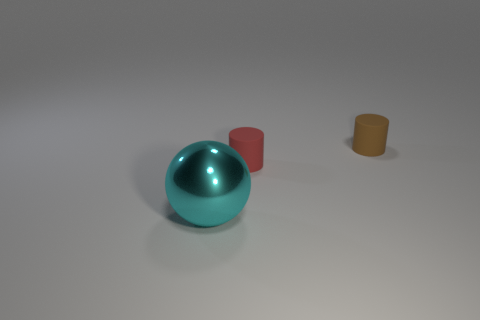Is the color of the big sphere the same as the rubber cylinder that is in front of the tiny brown thing?
Provide a succinct answer. No. Are there an equal number of cyan things that are on the right side of the large metallic object and big shiny spheres that are on the right side of the tiny brown rubber cylinder?
Ensure brevity in your answer.  Yes. There is a cylinder that is in front of the brown rubber cylinder; what is it made of?
Your answer should be compact. Rubber. How many objects are objects that are behind the metallic ball or cylinders?
Your answer should be very brief. 2. How many other things are there of the same shape as the metal object?
Provide a succinct answer. 0. There is a matte thing that is on the left side of the brown cylinder; does it have the same shape as the tiny brown rubber thing?
Your answer should be very brief. Yes. Are there any things right of the big cyan shiny ball?
Your answer should be compact. Yes. What number of small things are either spheres or brown rubber cylinders?
Give a very brief answer. 1. Is the cyan ball made of the same material as the red object?
Ensure brevity in your answer.  No. Are there any tiny cylinders of the same color as the large shiny object?
Provide a succinct answer. No. 